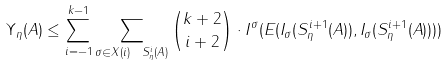Convert formula to latex. <formula><loc_0><loc_0><loc_500><loc_500>\| \Upsilon _ { \eta } ( A ) \| \leq \sum _ { i = - 1 } ^ { k - 1 } \sum _ { \sigma \in X ( i ) \ S _ { \eta } ^ { i } ( A ) } { k + 2 \choose i + 2 } \cdot \| I ^ { \sigma } ( E ( I _ { \sigma } ( S _ { \eta } ^ { i + 1 } ( A ) ) , I _ { \sigma } ( S _ { \eta } ^ { i + 1 } ( A ) ) ) ) \|</formula> 